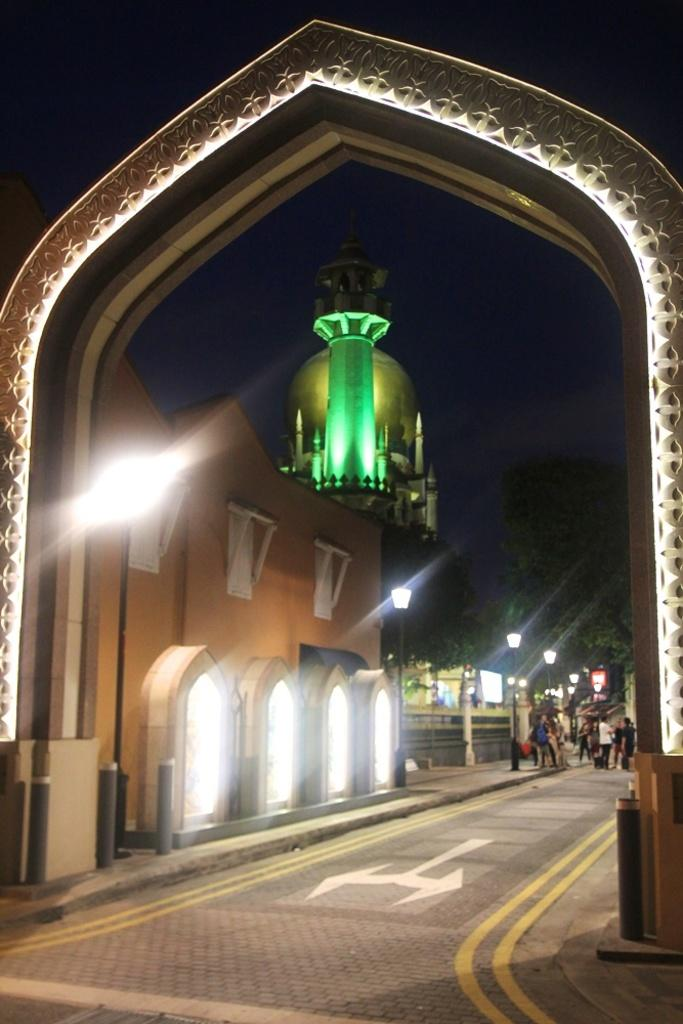What is the main structure in the image? There is a house with a roof and windows in the image. What other features can be seen in the image? There is an entrance, a tower, street poles, trees, a pathway, and people standing in the image. What type of machine can be seen in the notebook held by the rabbit in the image? There is no machine, notebook, or rabbit present in the image. 